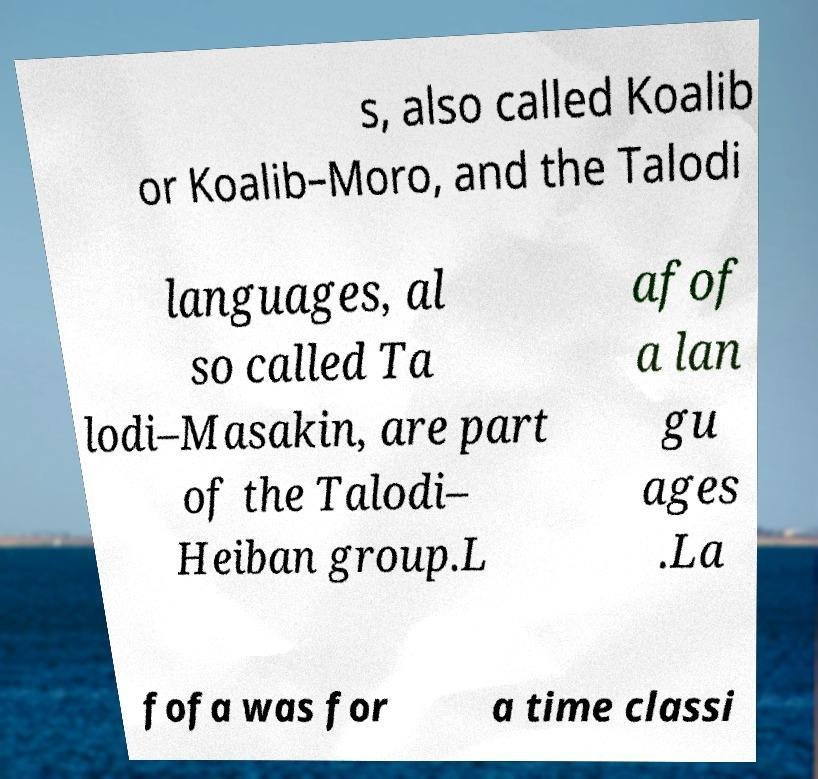Could you assist in decoding the text presented in this image and type it out clearly? s, also called Koalib or Koalib–Moro, and the Talodi languages, al so called Ta lodi–Masakin, are part of the Talodi– Heiban group.L afof a lan gu ages .La fofa was for a time classi 